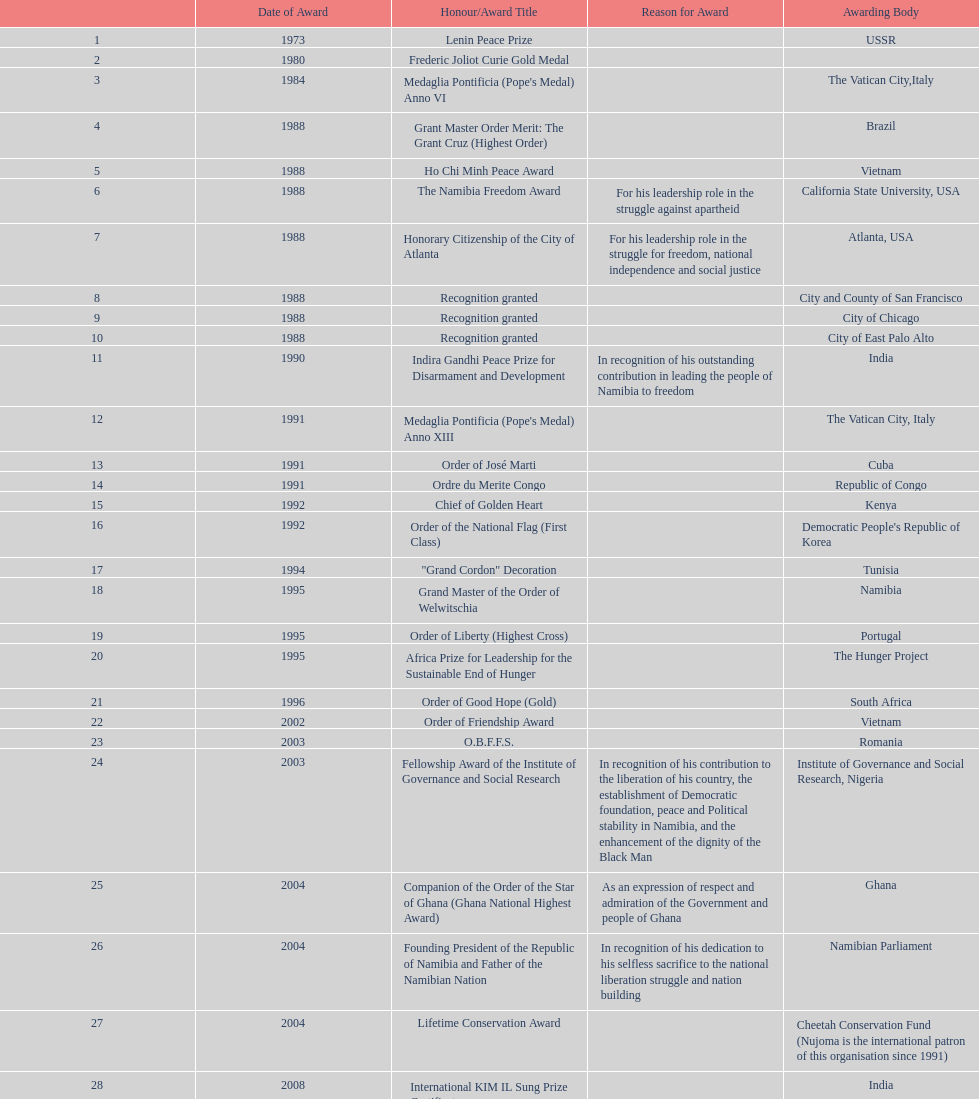Was the o.b.f.f.s. award won by nujoma in romania or ghana? Romania. 